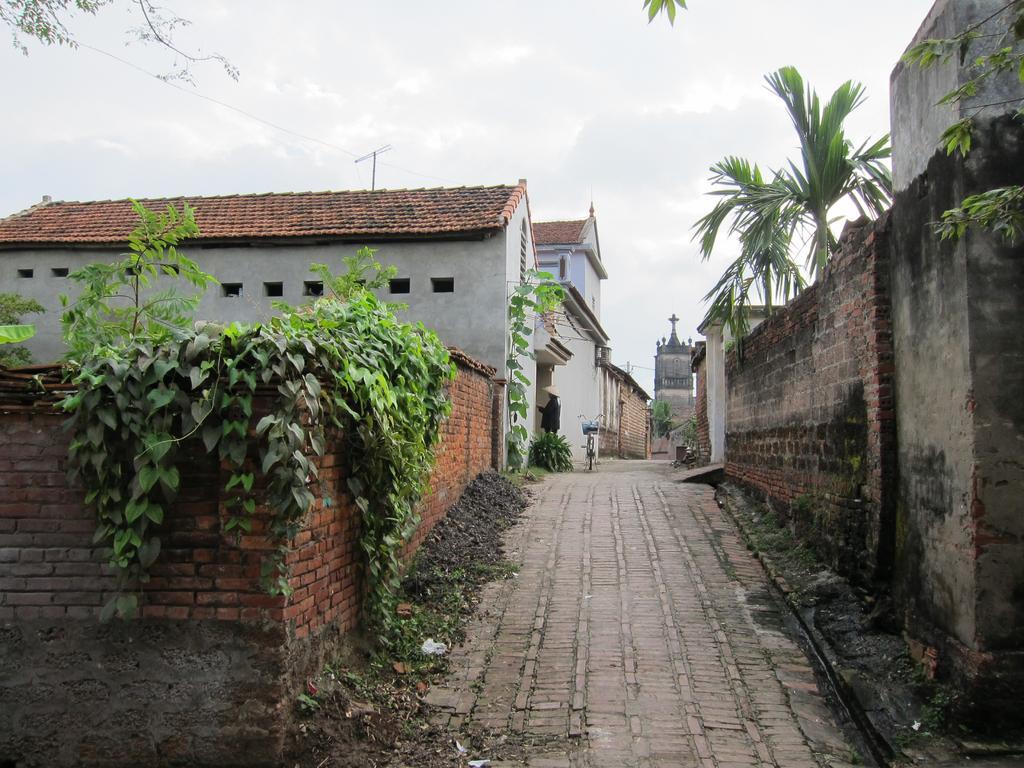Can you describe this image briefly? In this picture I can see on the left side there are plants, on the right side there are trees. There are buildings on either side of this image, at the top there is the cloudy sky. 